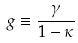Convert formula to latex. <formula><loc_0><loc_0><loc_500><loc_500>g \equiv \frac { \gamma } { 1 - \kappa }</formula> 